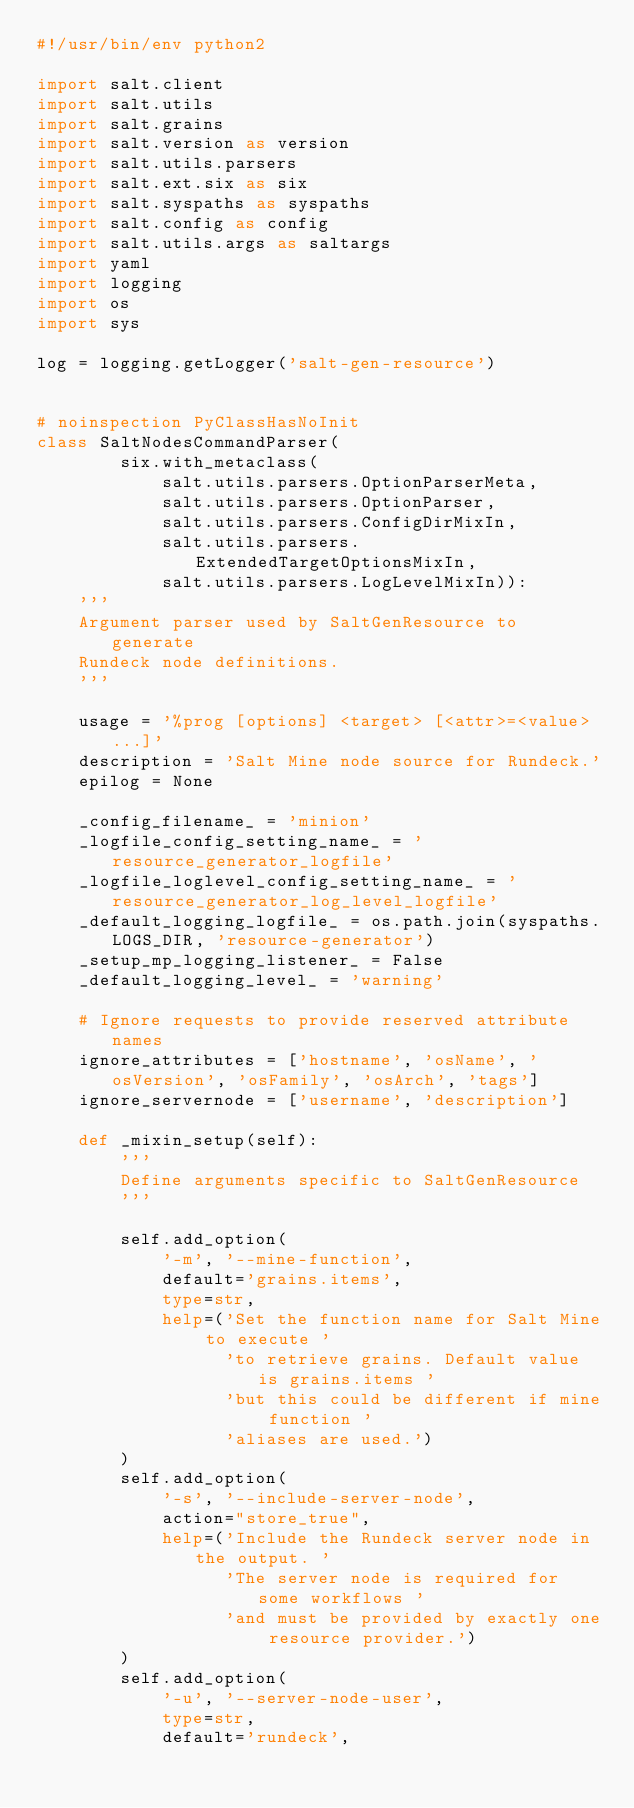<code> <loc_0><loc_0><loc_500><loc_500><_Python_>#!/usr/bin/env python2

import salt.client
import salt.utils
import salt.grains
import salt.version as version
import salt.utils.parsers
import salt.ext.six as six
import salt.syspaths as syspaths
import salt.config as config
import salt.utils.args as saltargs
import yaml
import logging
import os
import sys

log = logging.getLogger('salt-gen-resource')


# noinspection PyClassHasNoInit
class SaltNodesCommandParser(
        six.with_metaclass(
            salt.utils.parsers.OptionParserMeta,
            salt.utils.parsers.OptionParser,
            salt.utils.parsers.ConfigDirMixIn,
            salt.utils.parsers.ExtendedTargetOptionsMixIn,
            salt.utils.parsers.LogLevelMixIn)):
    '''
    Argument parser used by SaltGenResource to generate
    Rundeck node definitions.
    '''

    usage = '%prog [options] <target> [<attr>=<value> ...]'
    description = 'Salt Mine node source for Rundeck.'
    epilog = None

    _config_filename_ = 'minion'
    _logfile_config_setting_name_ = 'resource_generator_logfile'
    _logfile_loglevel_config_setting_name_ = 'resource_generator_log_level_logfile'
    _default_logging_logfile_ = os.path.join(syspaths.LOGS_DIR, 'resource-generator')
    _setup_mp_logging_listener_ = False
    _default_logging_level_ = 'warning'

    # Ignore requests to provide reserved attribute names
    ignore_attributes = ['hostname', 'osName', 'osVersion', 'osFamily', 'osArch', 'tags']
    ignore_servernode = ['username', 'description']

    def _mixin_setup(self):
        '''
        Define arguments specific to SaltGenResource
        '''

        self.add_option(
            '-m', '--mine-function',
            default='grains.items',
            type=str,
            help=('Set the function name for Salt Mine to execute '
                  'to retrieve grains. Default value is grains.items '
                  'but this could be different if mine function '
                  'aliases are used.')
        )
        self.add_option(
            '-s', '--include-server-node',
            action="store_true",
            help=('Include the Rundeck server node in the output. '
                  'The server node is required for some workflows '
                  'and must be provided by exactly one resource provider.')
        )
        self.add_option(
            '-u', '--server-node-user',
            type=str,
            default='rundeck',</code> 